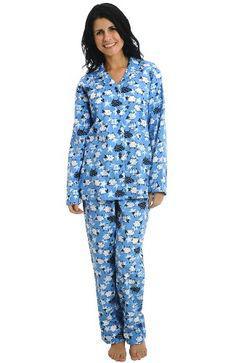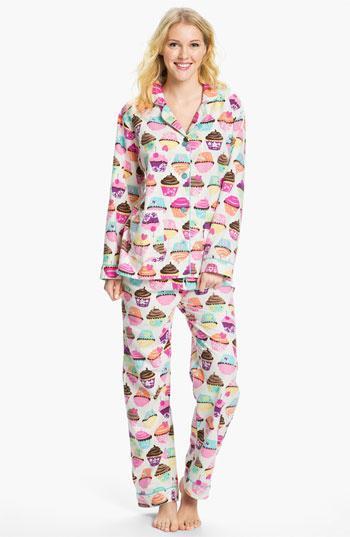The first image is the image on the left, the second image is the image on the right. Analyze the images presented: Is the assertion "An image shows a brunette wearing printed blue pajamas." valid? Answer yes or no. Yes. The first image is the image on the left, the second image is the image on the right. For the images shown, is this caption "The woman in the right image has one hand on her waist in posing position." true? Answer yes or no. No. 